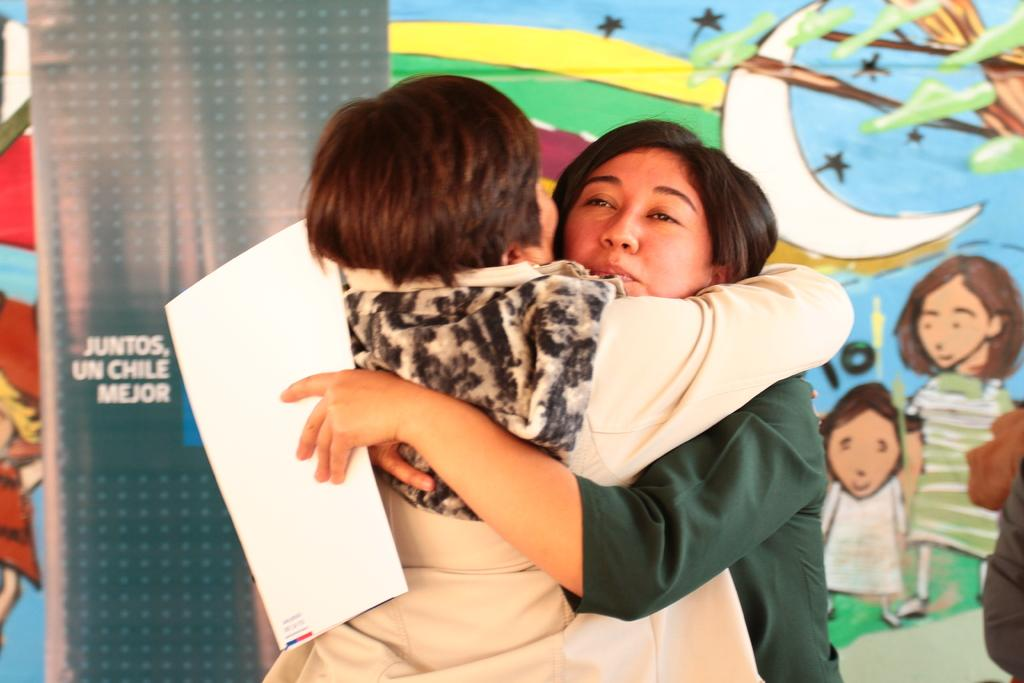How many people are in the image? There are two persons in the image. What are the two persons doing? The two persons are hugging each other. Can you describe the woman in the image? There is a woman in the image, and she is holding a paper in her hands. What can be seen in the background of the image? There is a banner in the background of the image. What level of hate is expressed by the banner in the image? There is no indication of hate or any emotion in the image, as the banner is not described in detail. 